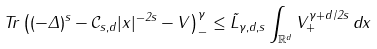<formula> <loc_0><loc_0><loc_500><loc_500>T r \left ( ( - \Delta ) ^ { s } - \mathcal { C } _ { s , d } | x | ^ { - 2 s } - V \right ) _ { - } ^ { \gamma } \leq \tilde { L } _ { \gamma , d , s } \int _ { \mathbb { R } ^ { d } } V _ { + } ^ { \gamma + d / 2 s } \, d x</formula> 